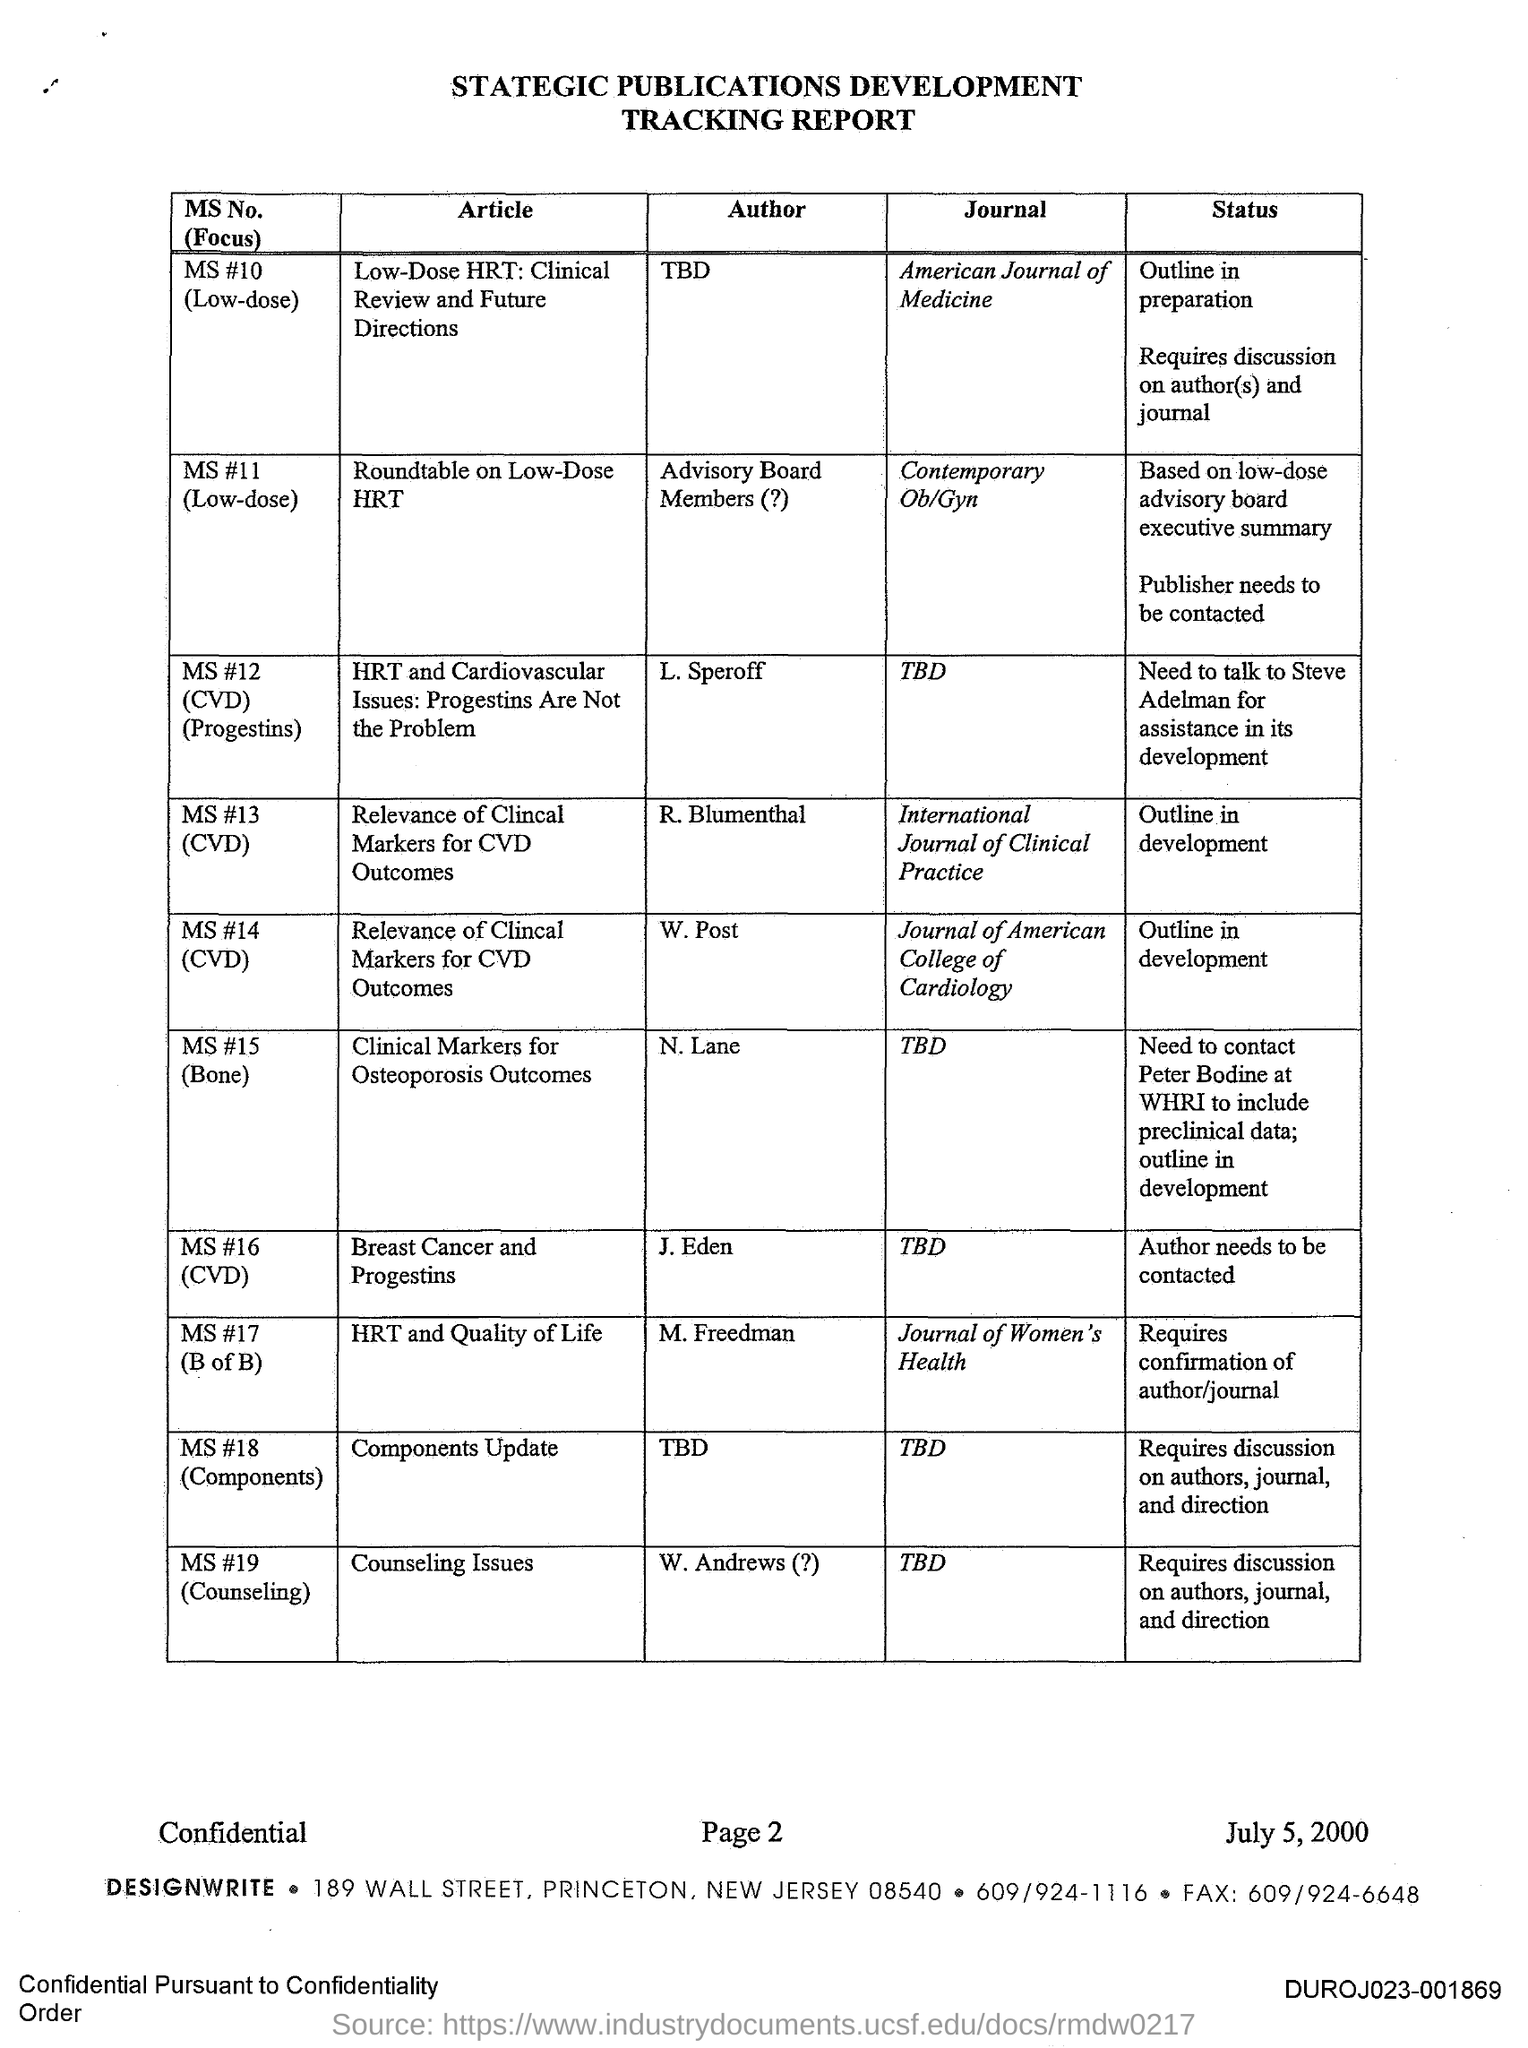Who is the author of the article titled 'Breast Cancer and Progestins'?
Ensure brevity in your answer.  J. Eden. In which journal, the article titled 'HRT and Quality of Life' is published?
Provide a succinct answer. Journal of Women's Health. In which journal, the article titled 'Low-Dose HRT: Clinical Review and Future Directions' is published?
Give a very brief answer. American Journal of Medicine. 